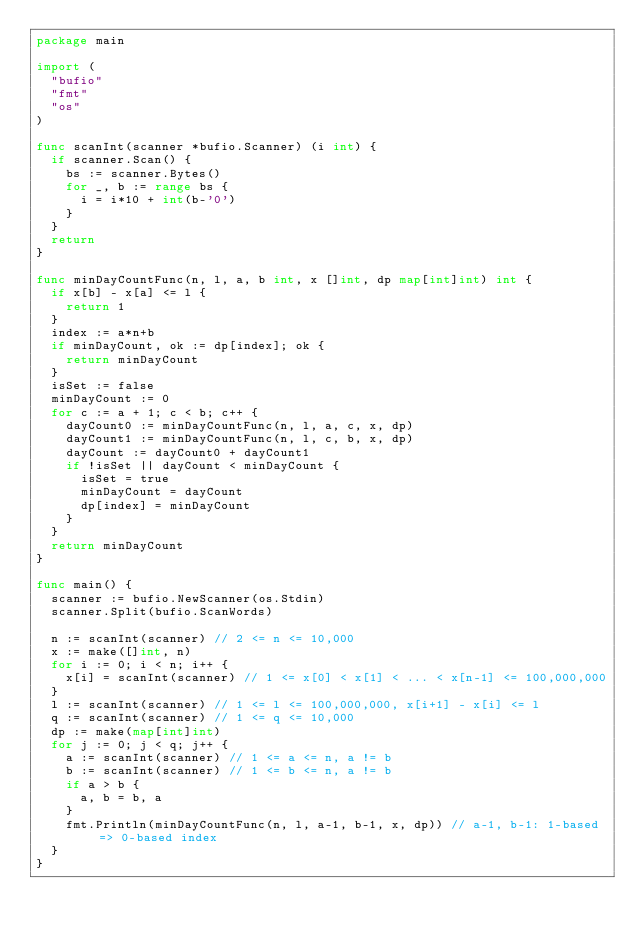<code> <loc_0><loc_0><loc_500><loc_500><_Go_>package main

import (
	"bufio"
	"fmt"
	"os"
)

func scanInt(scanner *bufio.Scanner) (i int) {
	if scanner.Scan() {
		bs := scanner.Bytes()
		for _, b := range bs {
			i = i*10 + int(b-'0')
		}
	}
	return
}

func minDayCountFunc(n, l, a, b int, x []int, dp map[int]int) int {
	if x[b] - x[a] <= l {
		return 1
	}
	index := a*n+b
	if minDayCount, ok := dp[index]; ok {
		return minDayCount
	}
	isSet := false
	minDayCount := 0
	for c := a + 1; c < b; c++ {
		dayCount0 := minDayCountFunc(n, l, a, c, x, dp)
		dayCount1 := minDayCountFunc(n, l, c, b, x, dp)
		dayCount := dayCount0 + dayCount1
		if !isSet || dayCount < minDayCount {
			isSet = true
			minDayCount = dayCount
			dp[index] = minDayCount
		}
	}
	return minDayCount
}

func main() {
	scanner := bufio.NewScanner(os.Stdin)
	scanner.Split(bufio.ScanWords)

	n := scanInt(scanner) // 2 <= n <= 10,000
	x := make([]int, n)
	for i := 0; i < n; i++ {
		x[i] = scanInt(scanner) // 1 <= x[0] < x[1] < ... < x[n-1] <= 100,000,000
	}
	l := scanInt(scanner) // 1 <= l <= 100,000,000, x[i+1] - x[i] <= l
	q := scanInt(scanner) // 1 <= q <= 10,000
	dp := make(map[int]int)
	for j := 0; j < q; j++ {
		a := scanInt(scanner) // 1 <= a <= n, a != b
		b := scanInt(scanner) // 1 <= b <= n, a != b
		if a > b {
			a, b = b, a
		}
		fmt.Println(minDayCountFunc(n, l, a-1, b-1, x, dp)) // a-1, b-1: 1-based => 0-based index
	}
}
</code> 